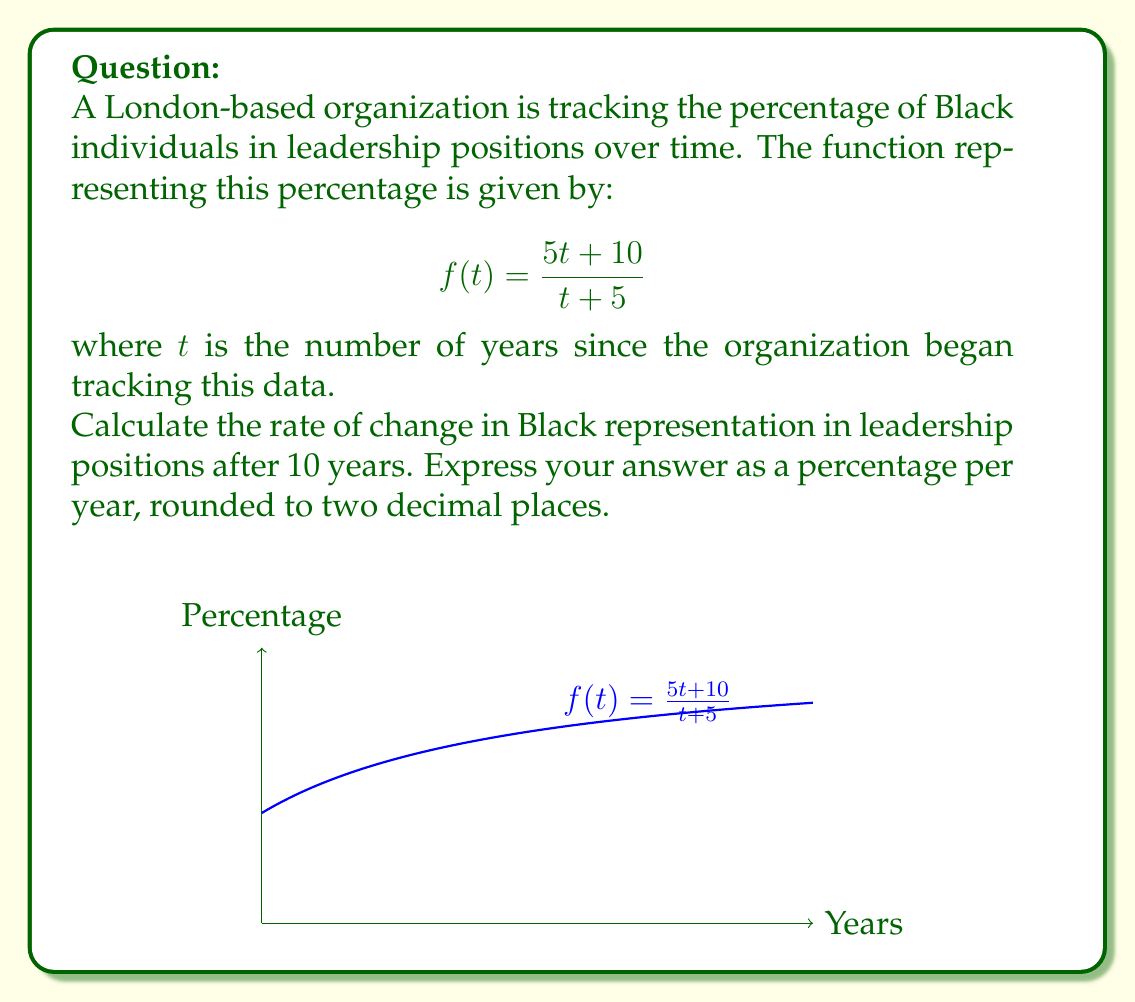Teach me how to tackle this problem. To find the rate of change after 10 years, we need to calculate the derivative of the function $f(t)$ and evaluate it at $t = 10$. Let's break this down step-by-step:

1) First, let's find the derivative of $f(t) = \frac{5t + 10}{t + 5}$ using the quotient rule:

   $$f'(t) = \frac{(t+5)(5) - (5t+10)(1)}{(t+5)^2}$$

2) Simplify the numerator:
   
   $$f'(t) = \frac{5t + 25 - 5t - 10}{(t+5)^2} = \frac{15}{(t+5)^2}$$

3) Now we have our derivative function. To find the rate of change after 10 years, we evaluate $f'(10)$:

   $$f'(10) = \frac{15}{(10+5)^2} = \frac{15}{225} = \frac{1}{15} \approx 0.0667$$

4) This result is in decimal form. To express it as a percentage per year, we multiply by 100:

   $$0.0667 \times 100 \approx 6.67\%$$

5) Rounding to two decimal places gives us 6.67% per year.

This positive rate of change indicates that the representation of Black individuals in leadership positions is still increasing after 10 years, but at a slower rate than initially.
Answer: 6.67% per year 